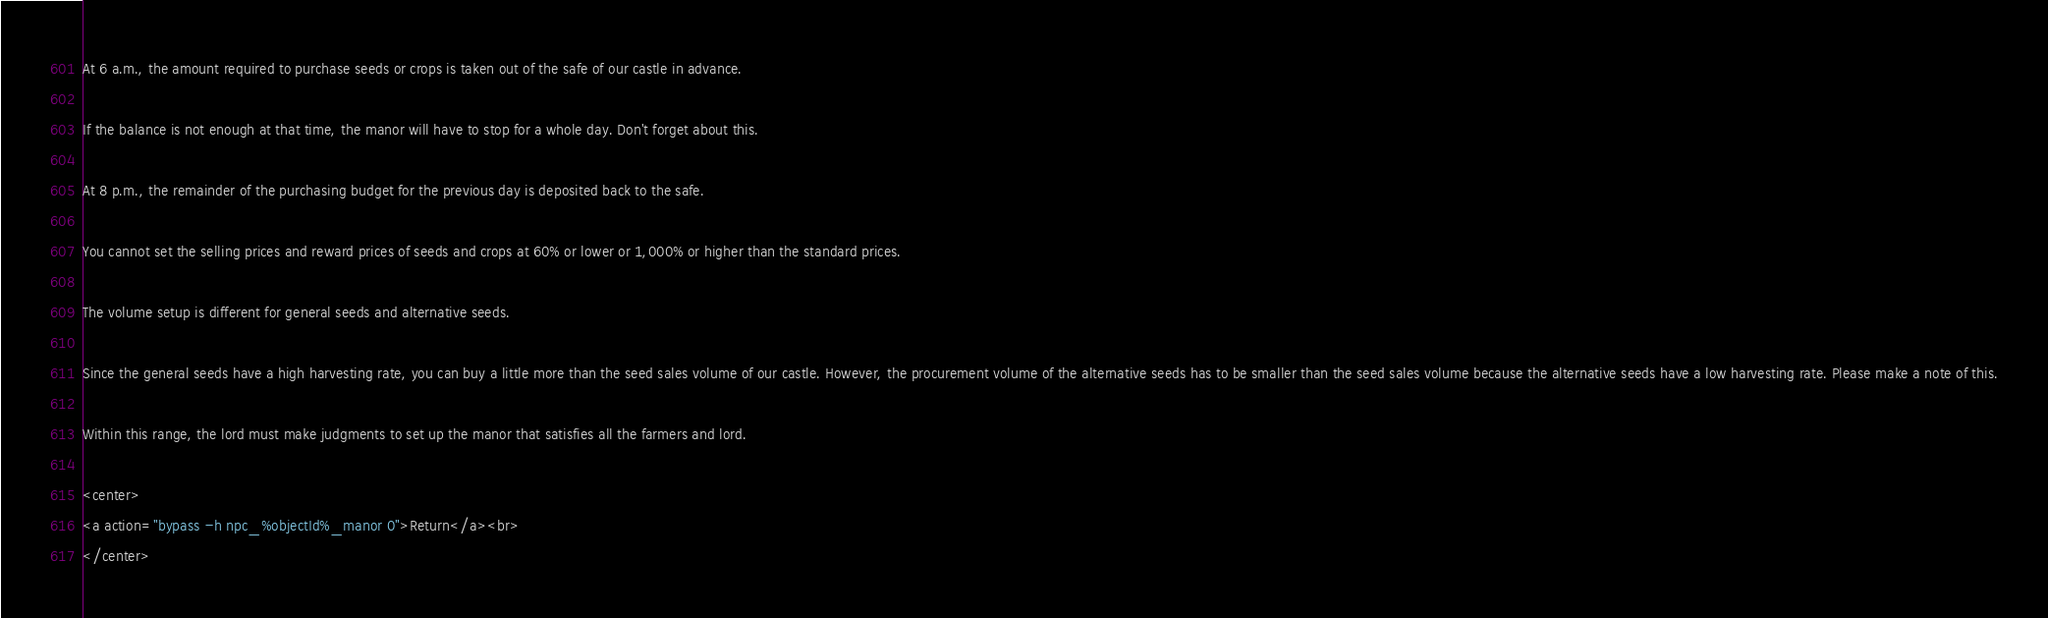<code> <loc_0><loc_0><loc_500><loc_500><_HTML_>At 6 a.m., the amount required to purchase seeds or crops is taken out of the safe of our castle in advance.

If the balance is not enough at that time, the manor will have to stop for a whole day. Don't forget about this.

At 8 p.m., the remainder of the purchasing budget for the previous day is deposited back to the safe.

You cannot set the selling prices and reward prices of seeds and crops at 60% or lower or 1,000% or higher than the standard prices.

The volume setup is different for general seeds and alternative seeds.

Since the general seeds have a high harvesting rate, you can buy a little more than the seed sales volume of our castle. However, the procurement volume of the alternative seeds has to be smaller than the seed sales volume because the alternative seeds have a low harvesting rate. Please make a note of this.

Within this range, the lord must make judgments to set up the manor that satisfies all the farmers and lord.

<center>
<a action="bypass -h npc_%objectId%_manor 0">Return</a><br>
</center></code> 